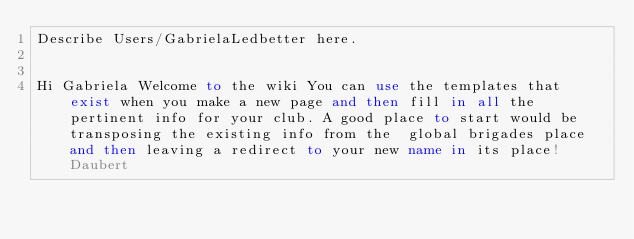Convert code to text. <code><loc_0><loc_0><loc_500><loc_500><_FORTRAN_>Describe Users/GabrielaLedbetter here.


Hi Gabriela Welcome to the wiki You can use the templates that exist when you make a new page and then fill in all the pertinent info for your club. A good place to start would be transposing the existing info from the  global brigades place and then leaving a redirect to your new name in its place! Daubert
</code> 